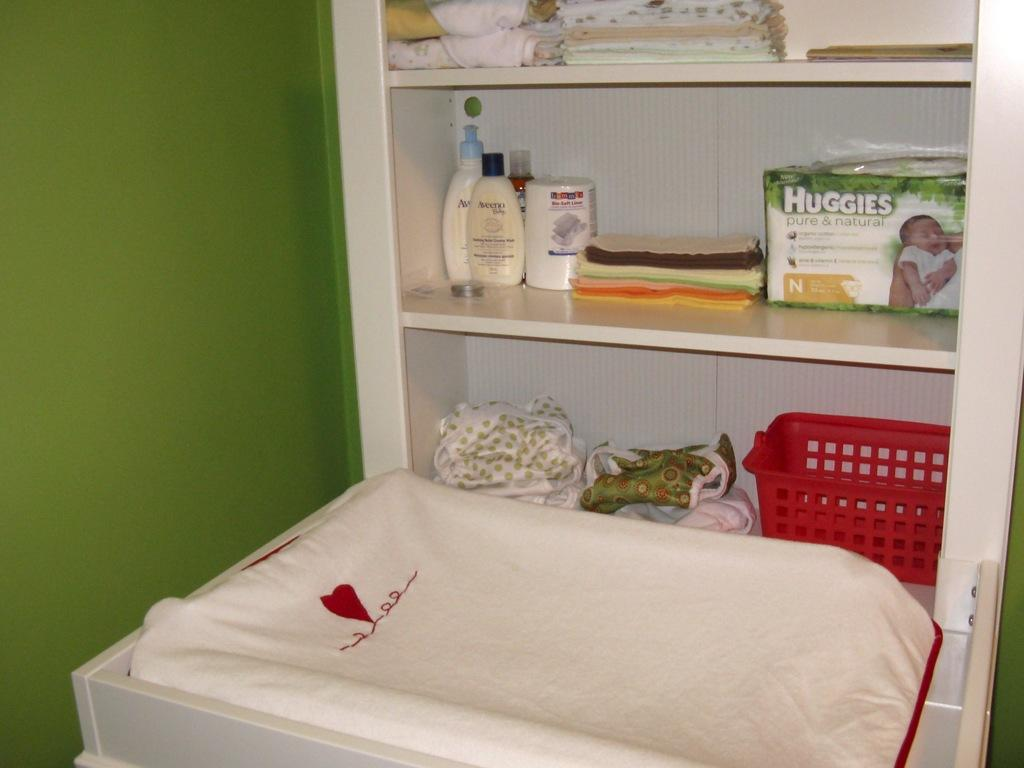Provide a one-sentence caption for the provided image. A white changing table cabinet with a white changing mat featuring a single red heart design and baby items on the shelves including Huggies diapers. 